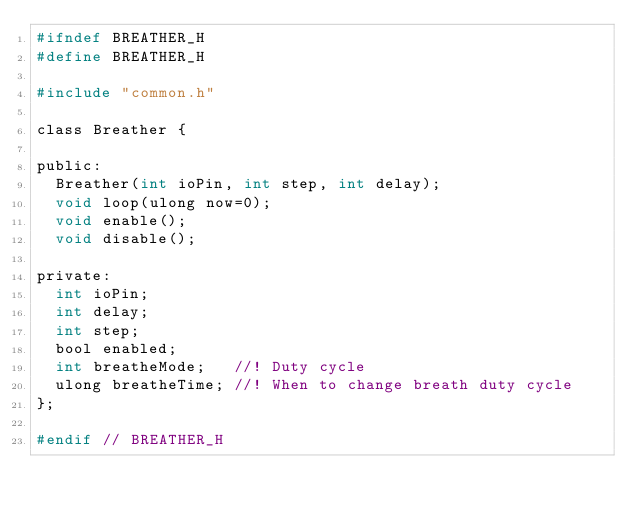<code> <loc_0><loc_0><loc_500><loc_500><_C_>#ifndef BREATHER_H
#define BREATHER_H

#include "common.h"

class Breather {

public:
  Breather(int ioPin, int step, int delay);
  void loop(ulong now=0);
  void enable();
  void disable();

private:
  int ioPin;
  int delay;
  int step;
  bool enabled;
  int breatheMode;   //! Duty cycle
  ulong breatheTime; //! When to change breath duty cycle
};

#endif // BREATHER_H
</code> 